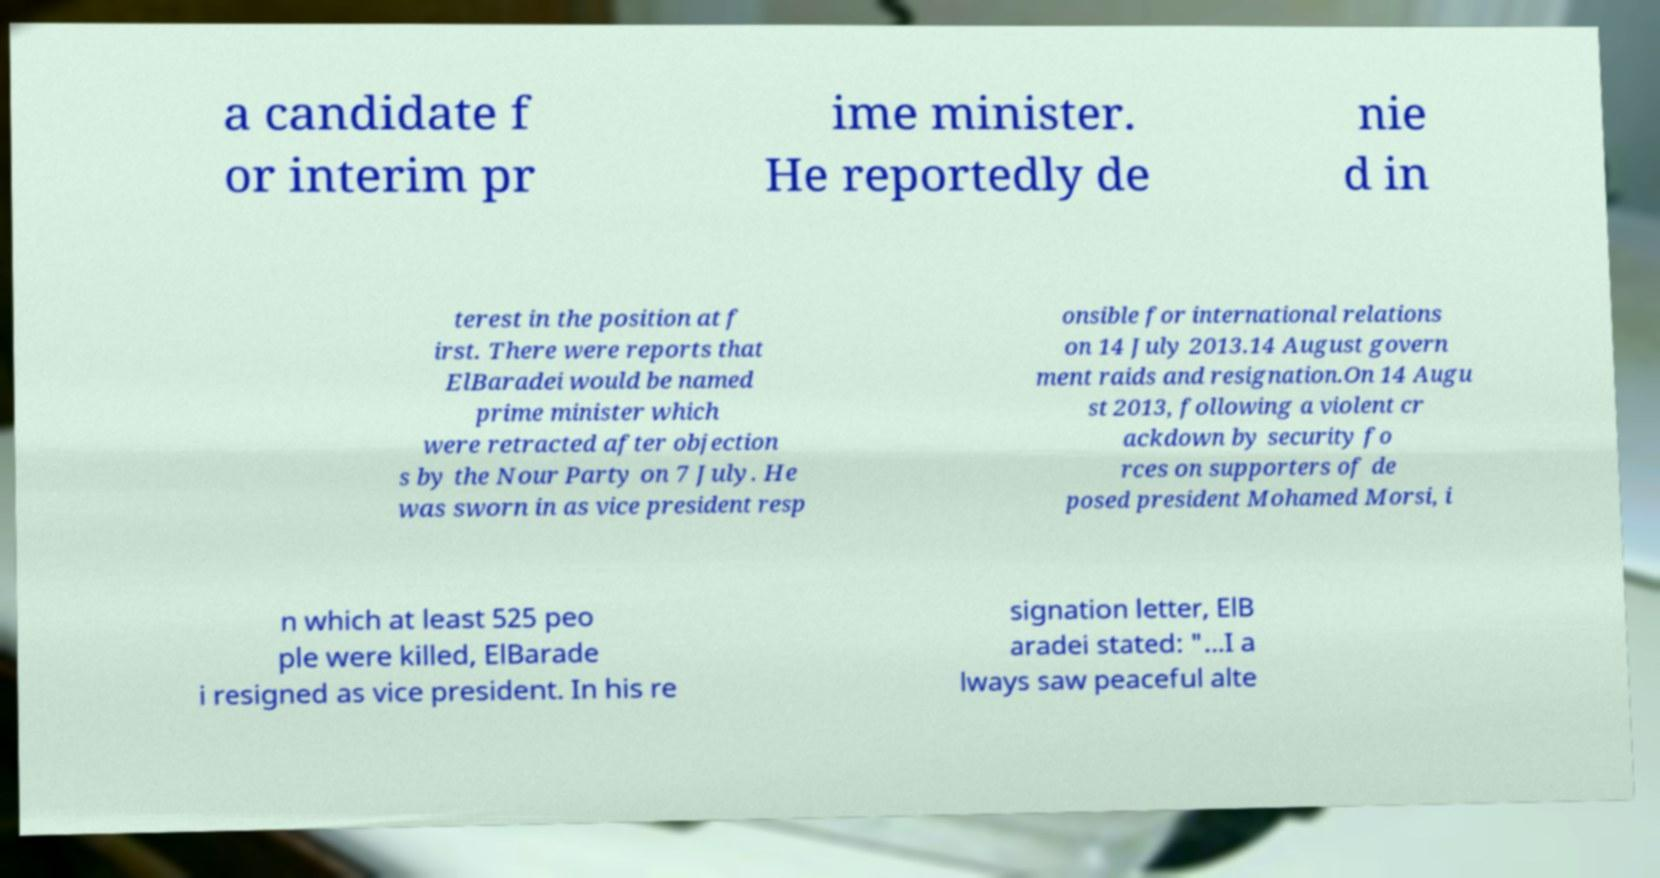Please read and relay the text visible in this image. What does it say? a candidate f or interim pr ime minister. He reportedly de nie d in terest in the position at f irst. There were reports that ElBaradei would be named prime minister which were retracted after objection s by the Nour Party on 7 July. He was sworn in as vice president resp onsible for international relations on 14 July 2013.14 August govern ment raids and resignation.On 14 Augu st 2013, following a violent cr ackdown by security fo rces on supporters of de posed president Mohamed Morsi, i n which at least 525 peo ple were killed, ElBarade i resigned as vice president. In his re signation letter, ElB aradei stated: "...I a lways saw peaceful alte 